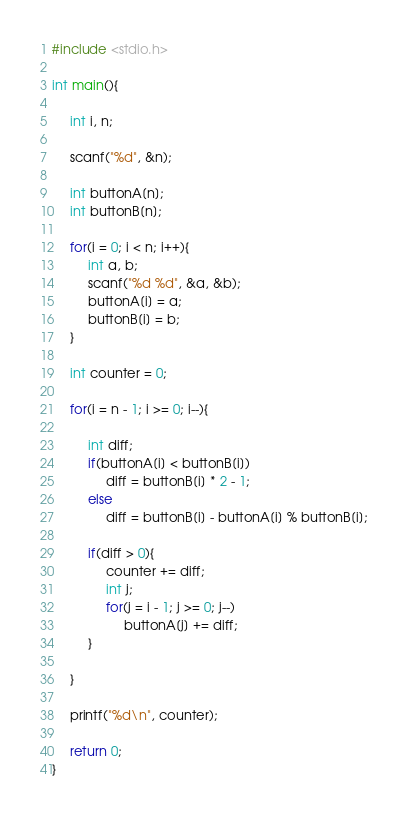Convert code to text. <code><loc_0><loc_0><loc_500><loc_500><_C_>#include <stdio.h>

int main(){

     int i, n;

     scanf("%d", &n);

     int buttonA[n];
     int buttonB[n];

     for(i = 0; i < n; i++){
          int a, b;
          scanf("%d %d", &a, &b);
          buttonA[i] = a;
          buttonB[i] = b;
     }

     int counter = 0;

     for(i = n - 1; i >= 0; i--){

          int diff;
          if(buttonA[i] < buttonB[i])
               diff = buttonB[i] * 2 - 1;
          else
               diff = buttonB[i] - buttonA[i] % buttonB[i];

          if(diff > 0){
               counter += diff;
               int j;
               for(j = i - 1; j >= 0; j--)
                    buttonA[j] += diff;
          }

     }

     printf("%d\n", counter);

     return 0;
}</code> 